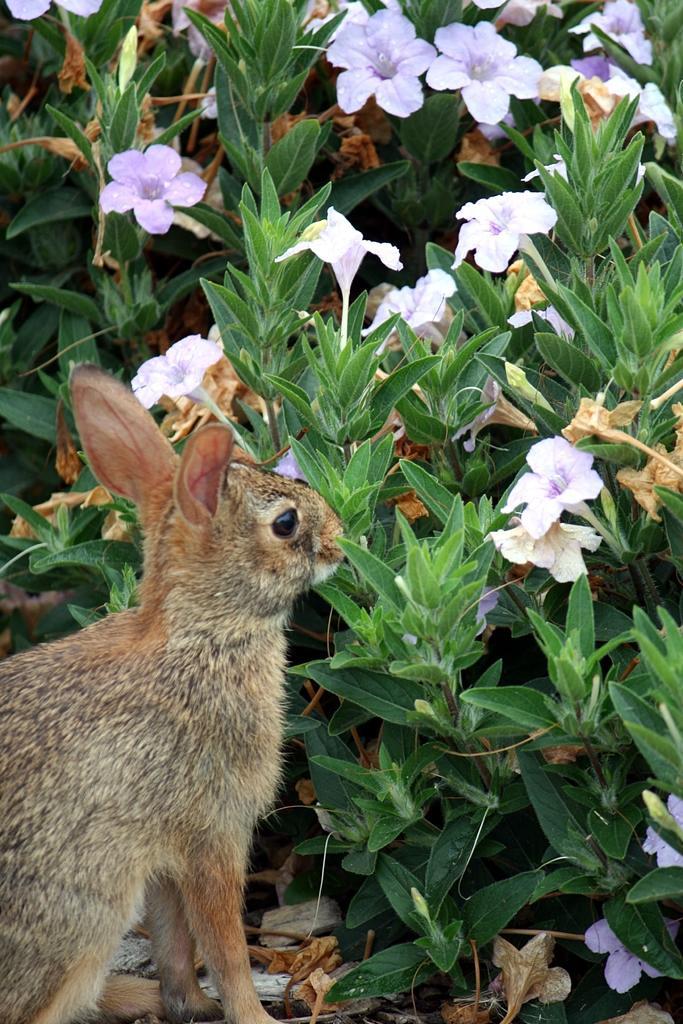Can you describe this image briefly? In this image, we can see an animal and there are some plants, we can see some flowers. 